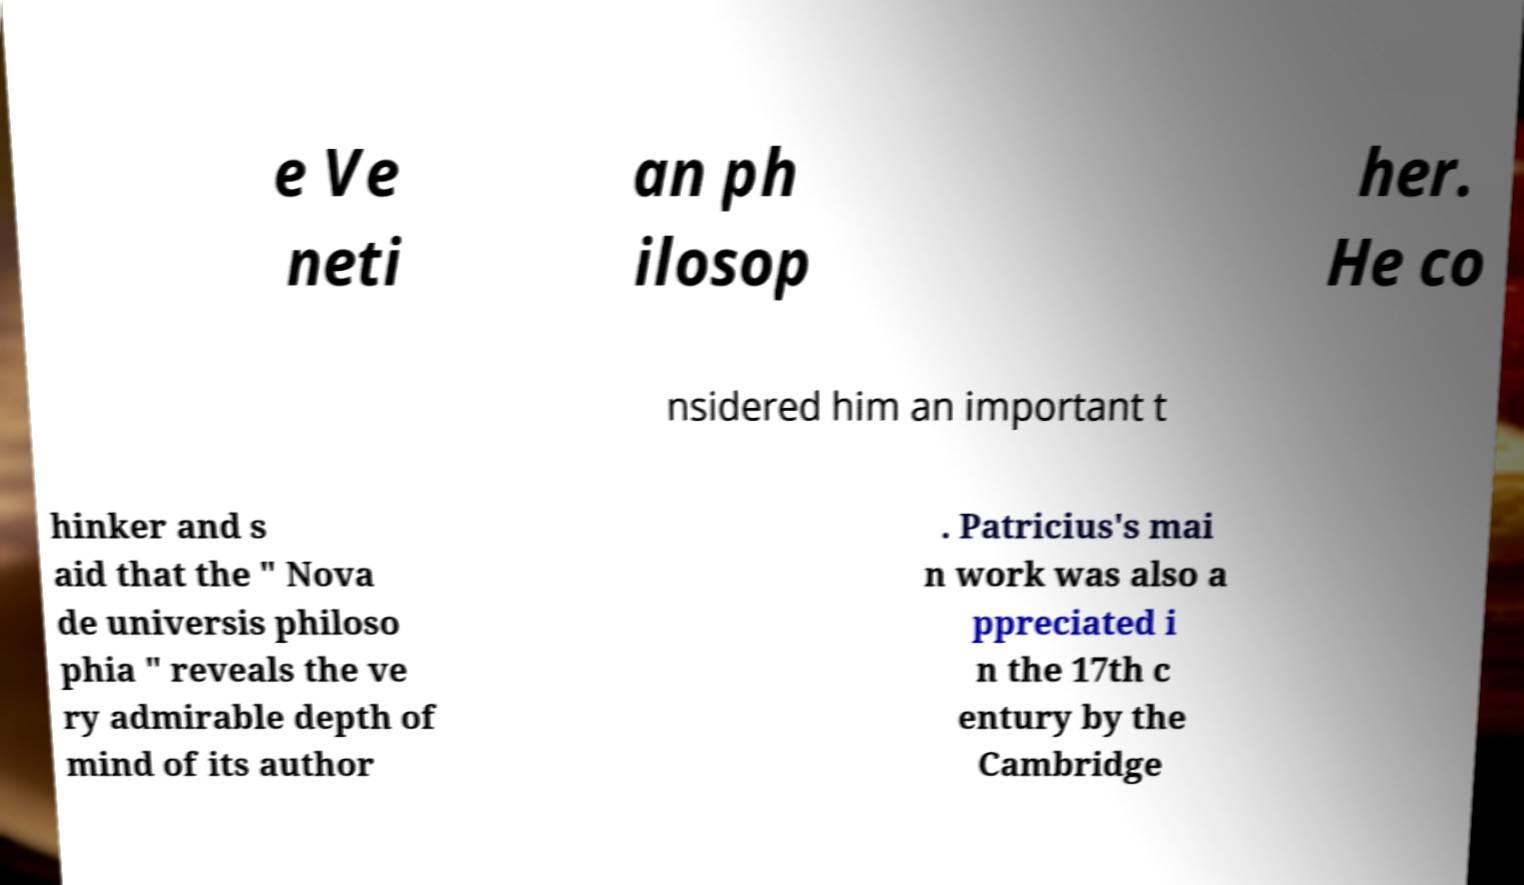I need the written content from this picture converted into text. Can you do that? e Ve neti an ph ilosop her. He co nsidered him an important t hinker and s aid that the " Nova de universis philoso phia " reveals the ve ry admirable depth of mind of its author . Patricius's mai n work was also a ppreciated i n the 17th c entury by the Cambridge 